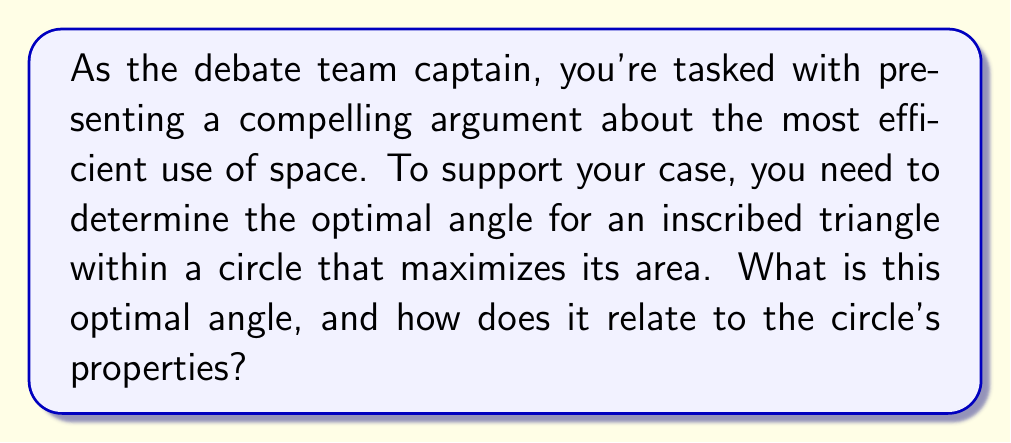Solve this math problem. Let's approach this step-by-step:

1) Consider an inscribed triangle ABC in a circle with center O and radius r.

2) Let the angle BOC be $\theta$. Due to symmetry, for maximum area, the triangle should be isosceles with AB = BC.

3) The area of the triangle is given by:
   $$A = \frac{1}{2}BC \cdot AH$$
   where AH is the height of the triangle.

4) BC can be expressed as $2r\sin(\frac{\theta}{2})$, and AH as $r\cos(\frac{\theta}{2})$.

5) Substituting these into the area formula:
   $$A = \frac{1}{2}(2r\sin(\frac{\theta}{2}))(r\cos(\frac{\theta}{2})) = r^2\sin(\frac{\theta}{2})\cos(\frac{\theta}{2})$$

6) Using the trigonometric identity $\sin(2x) = 2\sin(x)\cos(x)$, we get:
   $$A = \frac{1}{2}r^2\sin(\theta)$$

7) To find the maximum area, we differentiate A with respect to $\theta$ and set it to zero:
   $$\frac{dA}{d\theta} = \frac{1}{2}r^2\cos(\theta) = 0$$

8) This is true when $\cos(\theta) = 0$, which occurs when $\theta = 90°$ or $\frac{\pi}{2}$ radians.

9) The second derivative is negative at this point, confirming it's a maximum.

10) Therefore, the optimal angle BOC is 90°, making the inscribed triangle equilateral.

[asy]
unitsize(2cm);
pair O=(0,0);
draw(circle(O,1));
pair A=(0,1), B=(-sqrt(3)/2,-1/2), C=(sqrt(3)/2,-1/2);
draw(A--B--C--cycle);
draw(O--A,dashed);
draw(O--B,dashed);
draw(O--C,dashed);
label("A",A,N);
label("B",B,SW);
label("C",C,SE);
label("O",O,S);
label("90°",O,NE);
[/asy]
Answer: 90° 